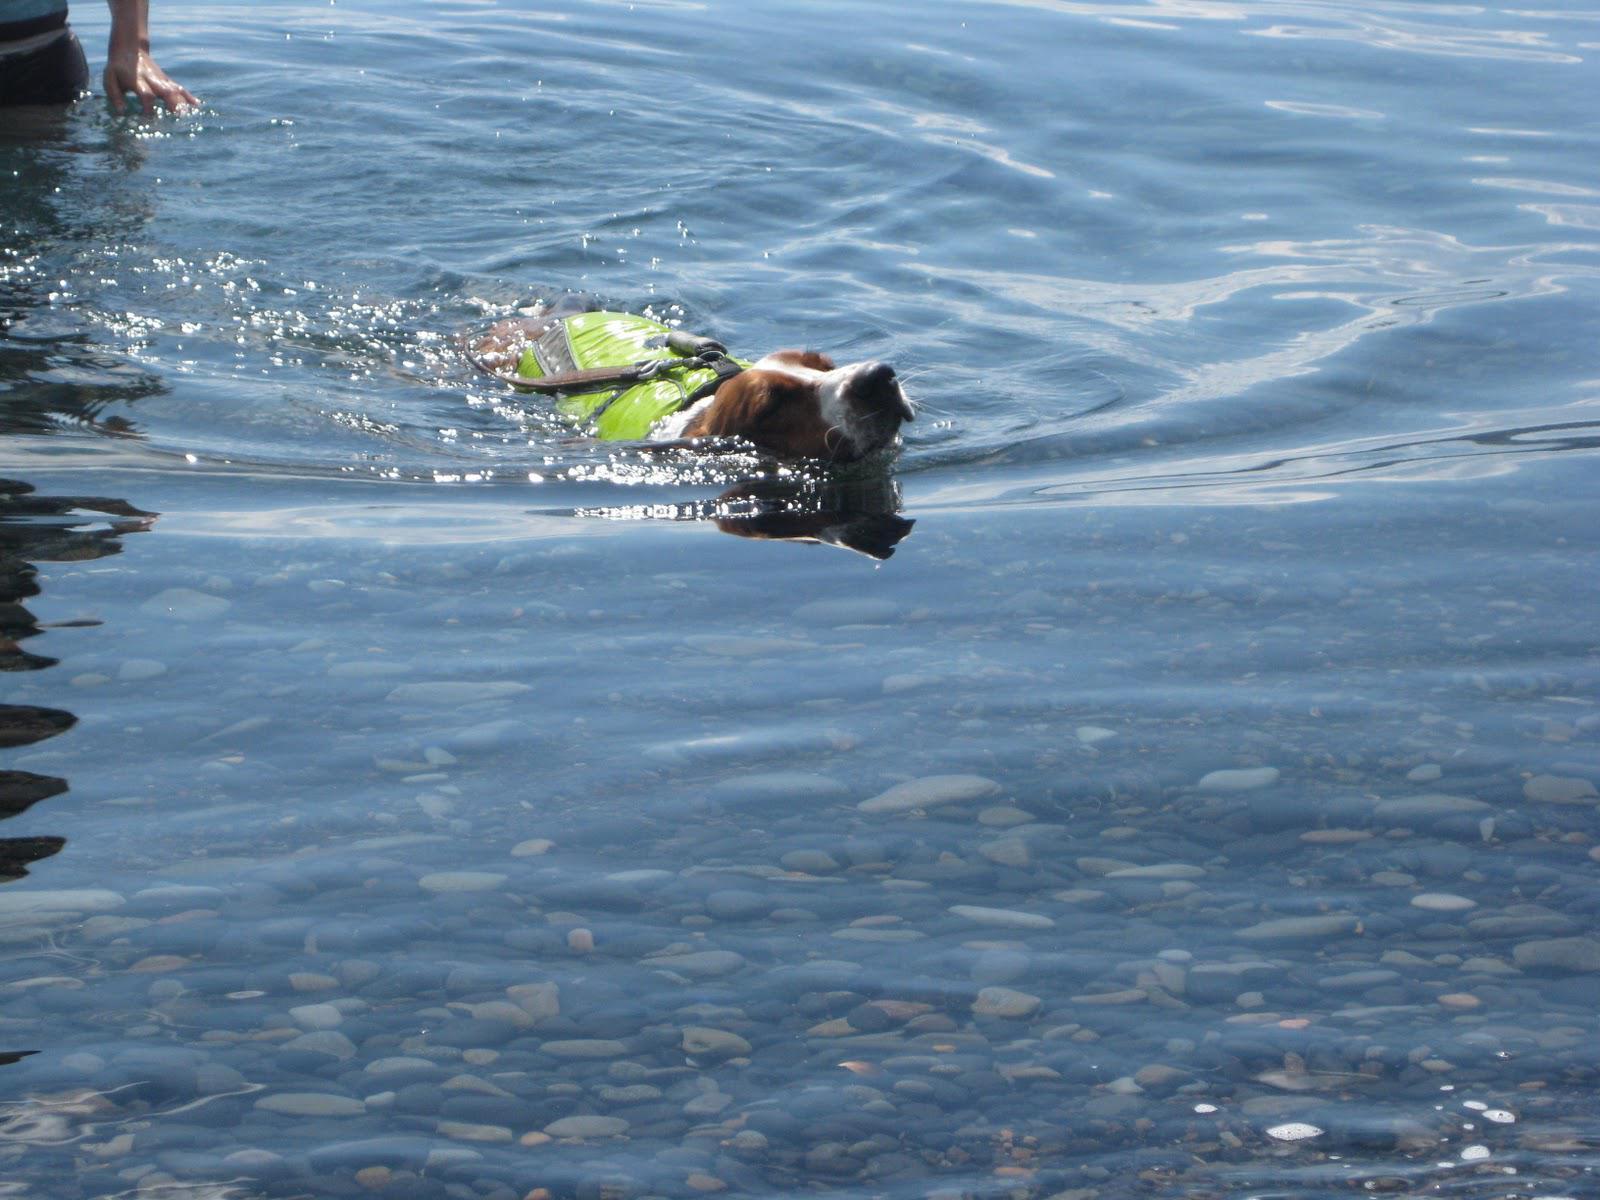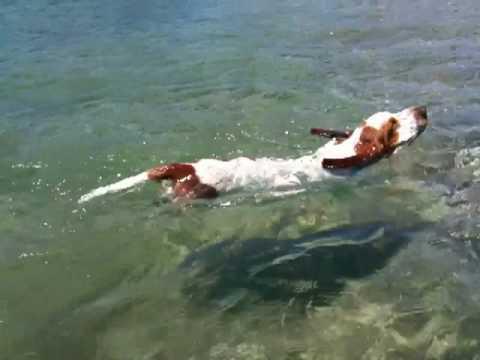The first image is the image on the left, the second image is the image on the right. For the images shown, is this caption "A basset hound is wearing a bright red-orange life vest in a scene that contains water." true? Answer yes or no. No. 